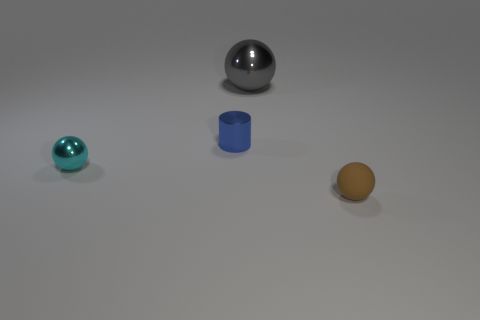Is there anything else that is the same material as the tiny brown thing?
Your answer should be compact. No. What is the color of the sphere that is the same size as the matte object?
Give a very brief answer. Cyan. Do the object on the right side of the big metallic object and the tiny cylinder have the same material?
Your answer should be very brief. No. Are there any small spheres on the right side of the small ball that is on the left side of the sphere on the right side of the large gray ball?
Your answer should be compact. Yes. Does the thing left of the blue metallic thing have the same shape as the blue metal object?
Provide a short and direct response. No. The tiny thing that is to the right of the metallic sphere that is right of the tiny cyan sphere is what shape?
Ensure brevity in your answer.  Sphere. What size is the metallic ball that is behind the shiny ball in front of the metallic object that is behind the small blue shiny cylinder?
Make the answer very short. Large. What is the color of the matte thing that is the same shape as the gray metal thing?
Offer a very short reply. Brown. Is the blue cylinder the same size as the brown thing?
Provide a short and direct response. Yes. What is the material of the tiny sphere to the left of the blue shiny cylinder?
Provide a succinct answer. Metal. 